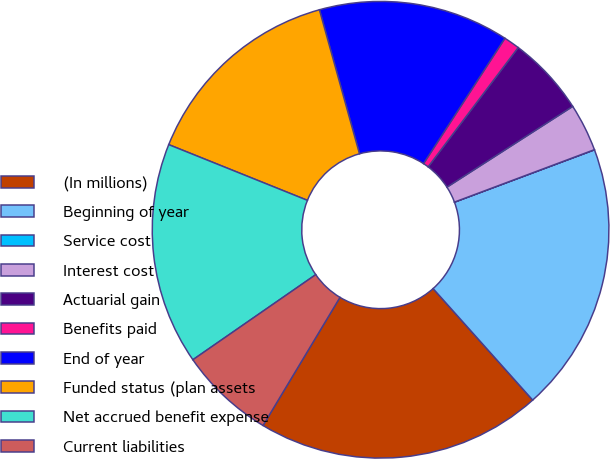<chart> <loc_0><loc_0><loc_500><loc_500><pie_chart><fcel>(In millions)<fcel>Beginning of year<fcel>Service cost<fcel>Interest cost<fcel>Actuarial gain<fcel>Benefits paid<fcel>End of year<fcel>Funded status (plan assets<fcel>Net accrued benefit expense<fcel>Current liabilities<nl><fcel>20.21%<fcel>19.09%<fcel>0.01%<fcel>3.38%<fcel>5.62%<fcel>1.13%<fcel>13.48%<fcel>14.6%<fcel>15.72%<fcel>6.75%<nl></chart> 